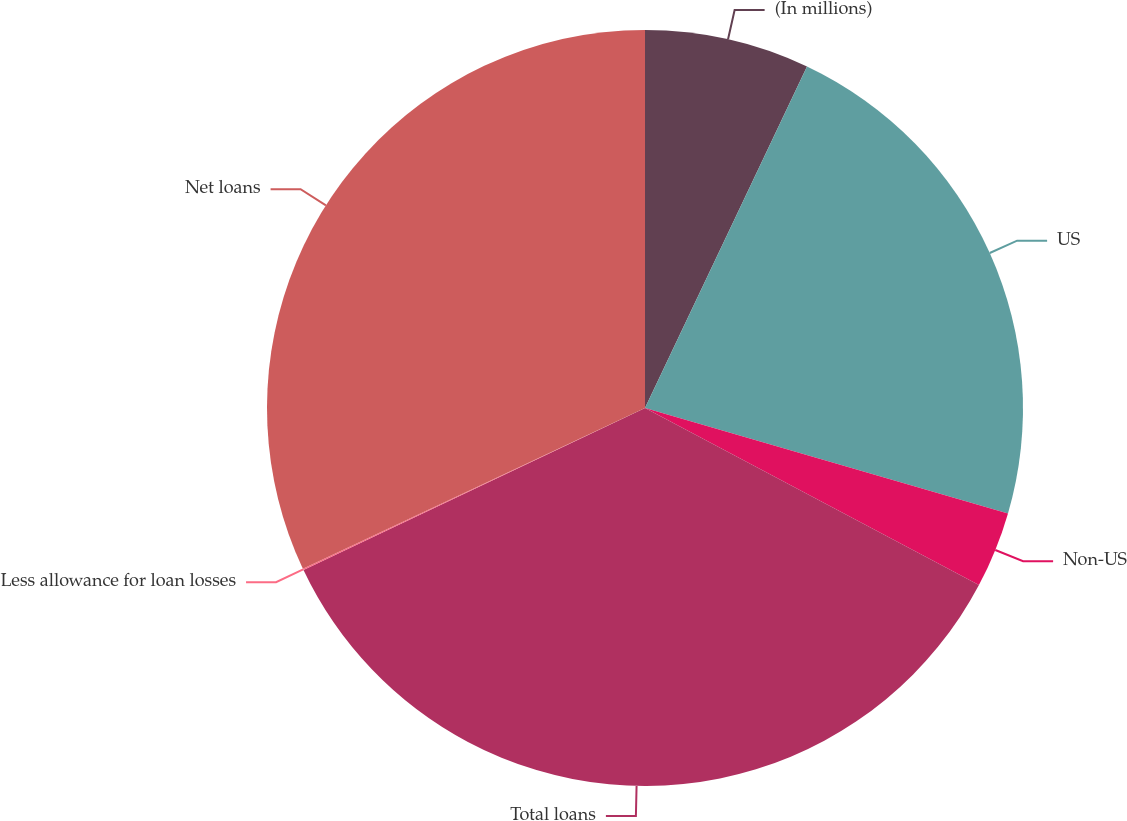<chart> <loc_0><loc_0><loc_500><loc_500><pie_chart><fcel>(In millions)<fcel>US<fcel>Non-US<fcel>Total loans<fcel>Less allowance for loan losses<fcel>Net loans<nl><fcel>7.05%<fcel>22.45%<fcel>3.26%<fcel>35.19%<fcel>0.06%<fcel>31.99%<nl></chart> 